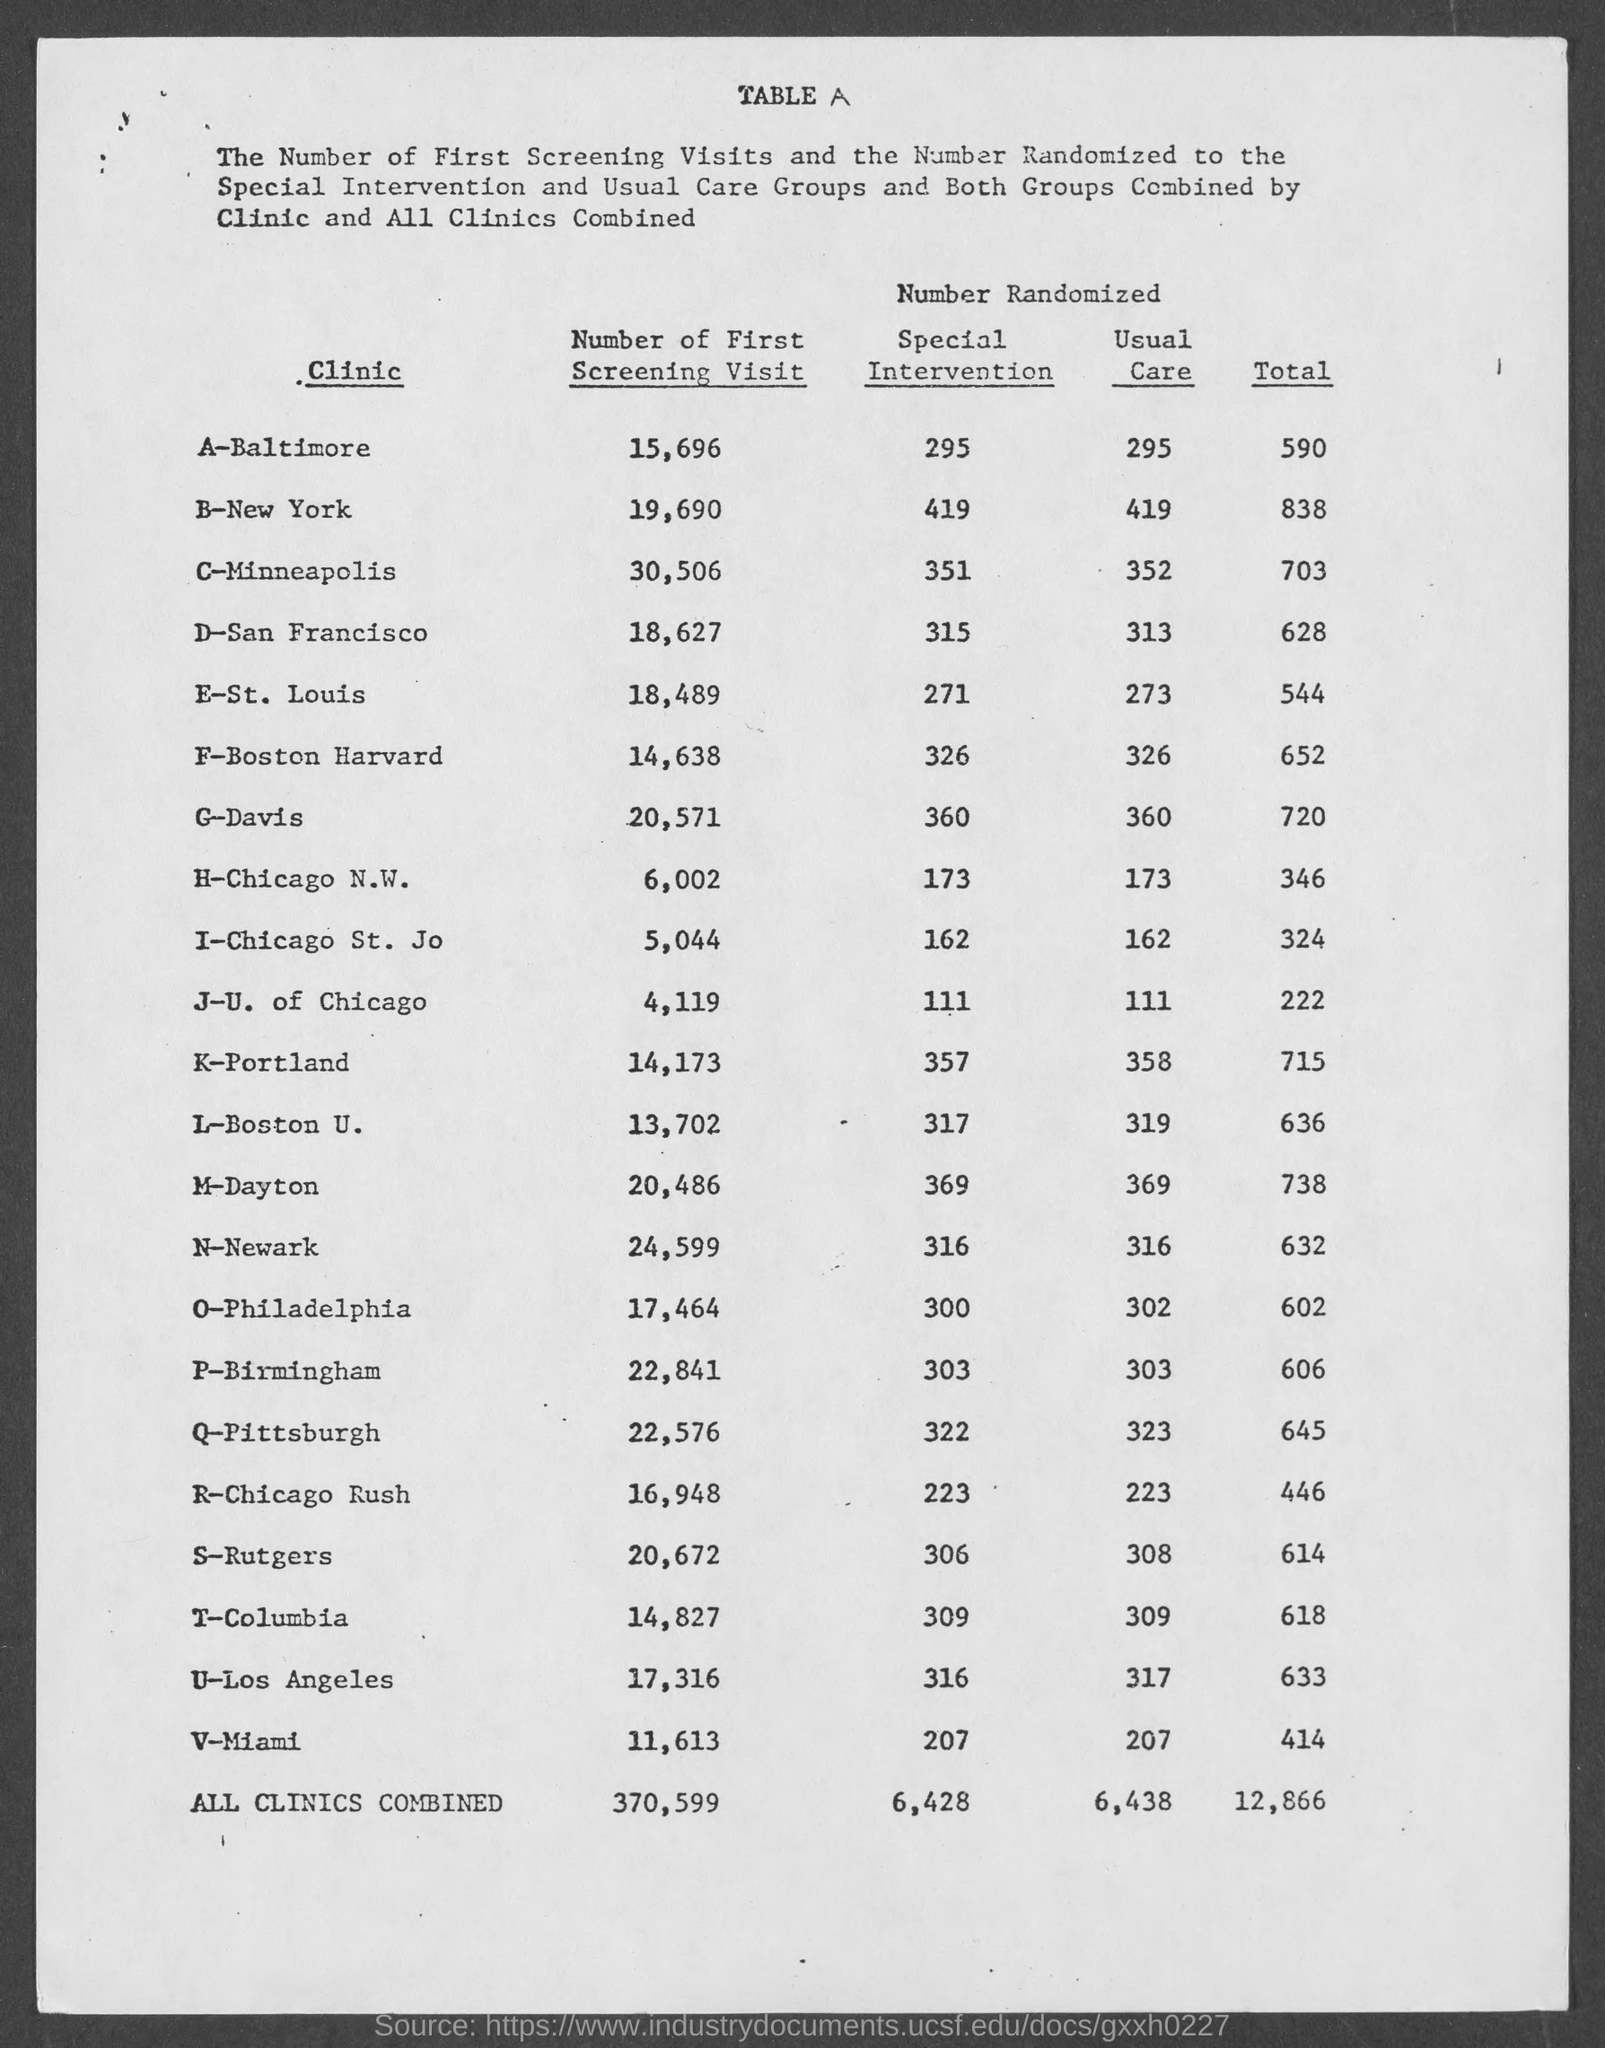Indicate a few pertinent items in this graphic. The number of usual care in the clinic C-Minneapolis is 352. The number of first screening visits at the clinic G-Davis is 20,571. The number of first screening visits at the V-Miami clinic is 11,613. The number of first screening visits at the clinic K-Portland is 14,173. The number of usual care at the clinic A-Baltimore is 295. 